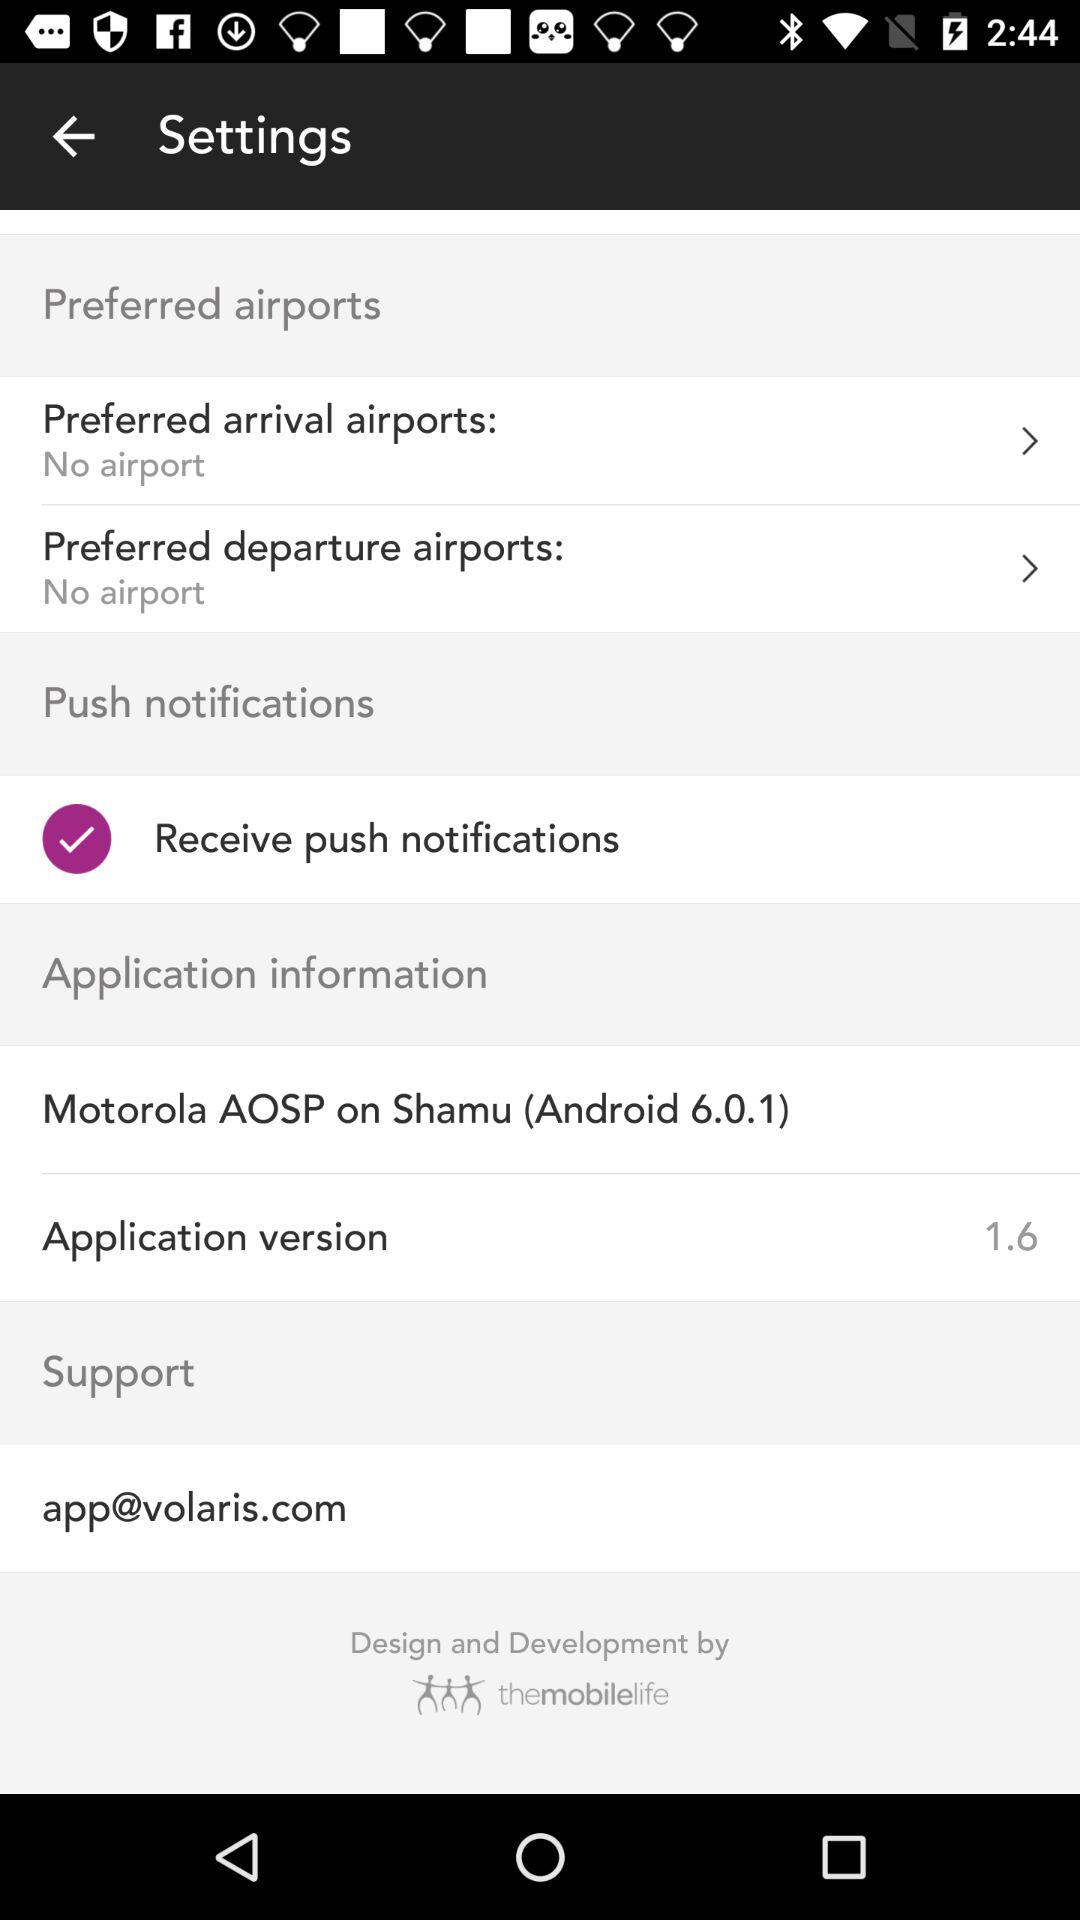What is the application version? The application version is 1.6. 